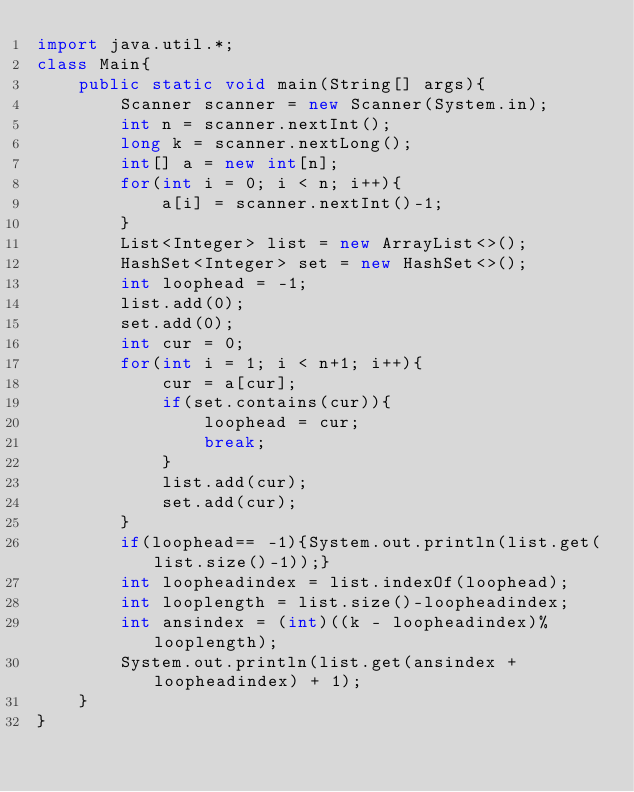<code> <loc_0><loc_0><loc_500><loc_500><_Java_>import java.util.*;
class Main{
    public static void main(String[] args){
        Scanner scanner = new Scanner(System.in);
        int n = scanner.nextInt();
        long k = scanner.nextLong();
        int[] a = new int[n];
        for(int i = 0; i < n; i++){
            a[i] = scanner.nextInt()-1;
        }
        List<Integer> list = new ArrayList<>();
        HashSet<Integer> set = new HashSet<>();
        int loophead = -1;
        list.add(0);
        set.add(0);
        int cur = 0;
        for(int i = 1; i < n+1; i++){
            cur = a[cur];
            if(set.contains(cur)){
                loophead = cur;
                break;
            }
            list.add(cur);
            set.add(cur);
        }
        if(loophead== -1){System.out.println(list.get(list.size()-1));}
        int loopheadindex = list.indexOf(loophead);
        int looplength = list.size()-loopheadindex;
        int ansindex = (int)((k - loopheadindex)%looplength);
        System.out.println(list.get(ansindex + loopheadindex) + 1);
    }
}</code> 